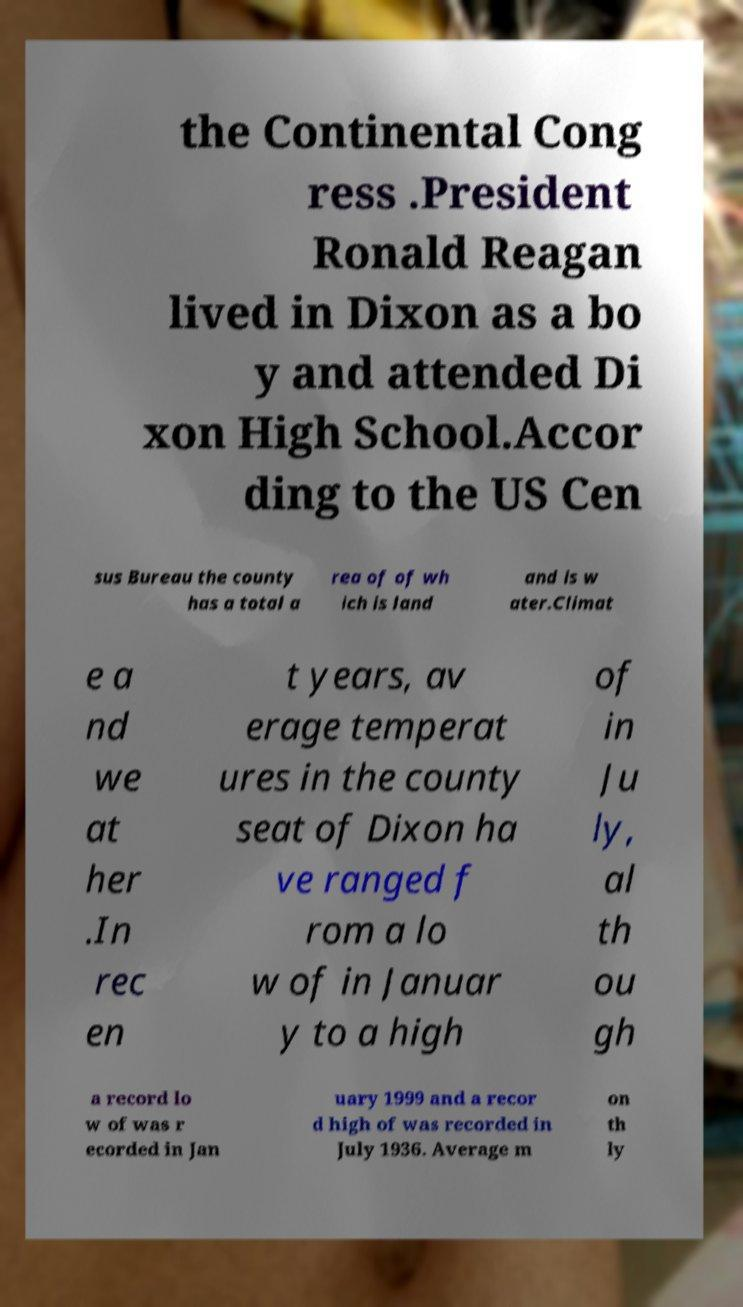Can you accurately transcribe the text from the provided image for me? the Continental Cong ress .President Ronald Reagan lived in Dixon as a bo y and attended Di xon High School.Accor ding to the US Cen sus Bureau the county has a total a rea of of wh ich is land and is w ater.Climat e a nd we at her .In rec en t years, av erage temperat ures in the county seat of Dixon ha ve ranged f rom a lo w of in Januar y to a high of in Ju ly, al th ou gh a record lo w of was r ecorded in Jan uary 1999 and a recor d high of was recorded in July 1936. Average m on th ly 